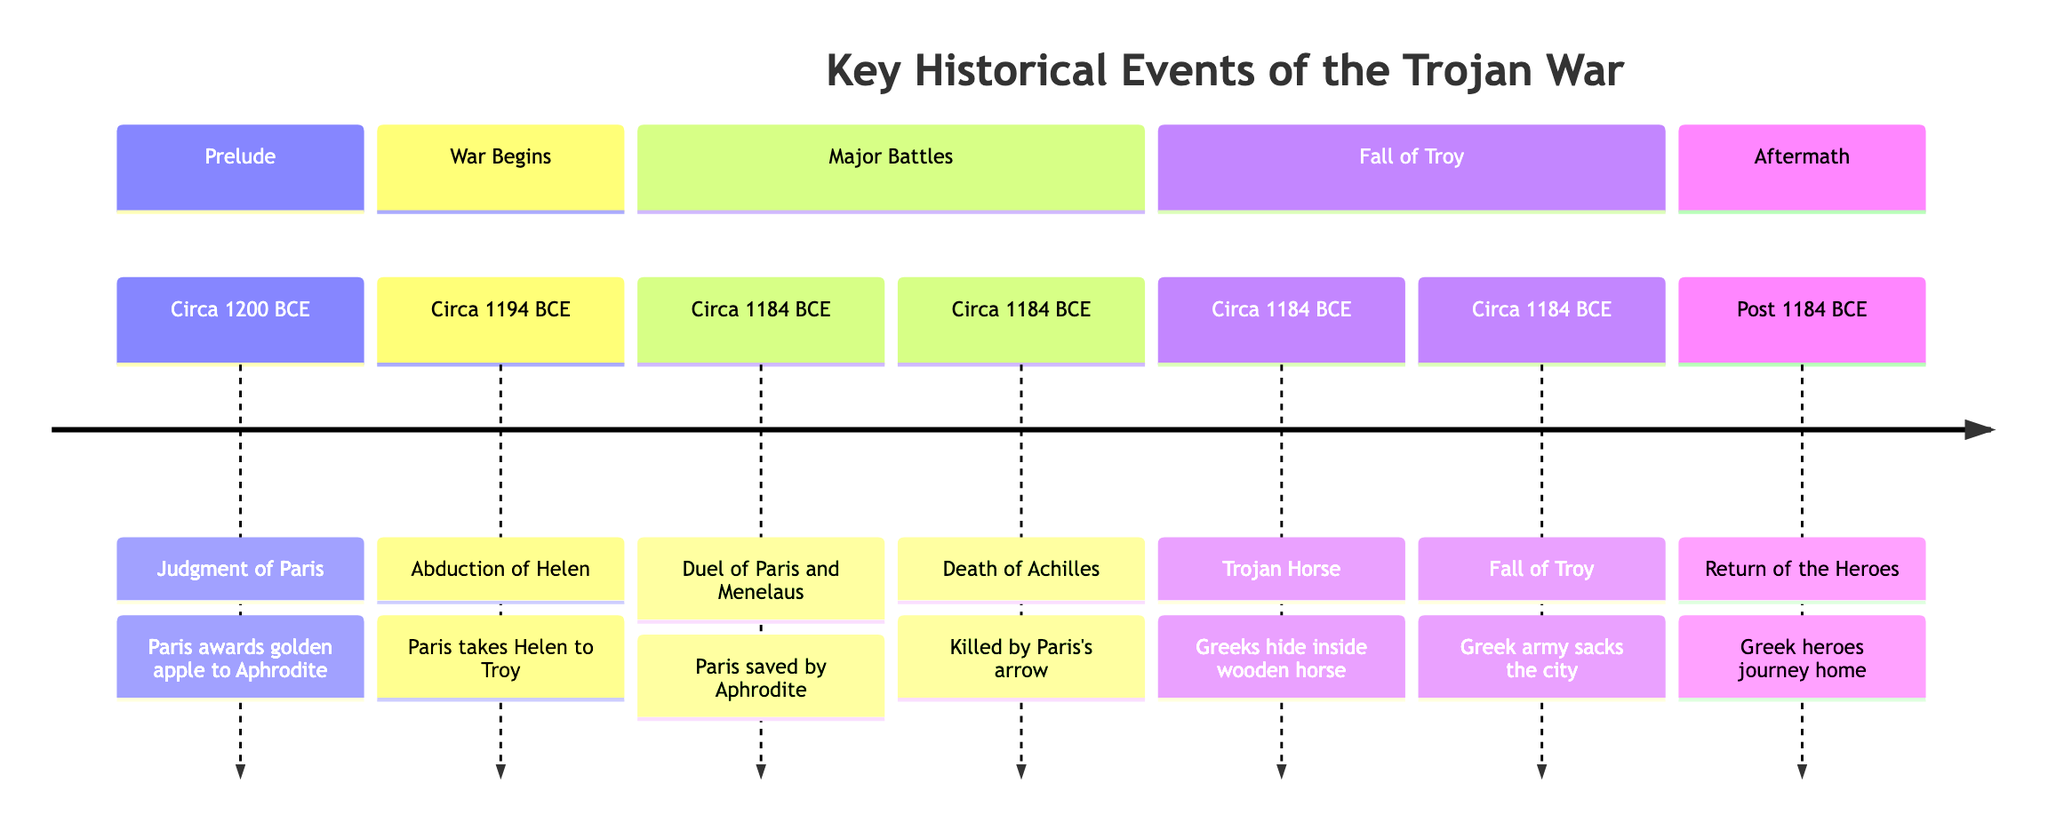What event marks the beginning of the Trojan War? According to the timeline, the event that marks the beginning of the Trojan War is the "Abduction of Helen," which occurred circa 1194 BCE. This event is situated after the "Judgment of Paris," indicating a direct cause-and-effect relationship.
Answer: Abduction of Helen How many key events are listed in the timeline? The timeline consists of seven key historical events related to the Trojan War, as evidenced by the distinct entries ranging from the "Judgment of Paris" to the "Return of the Heroes."
Answer: Seven What event occurred at the location "Fields of Troy"? The event that occurred at the "Fields of Troy" is the "Duel of Paris and Menelaus," which took place circa 1184 BCE. This can be confirmed by checking the timeline for the specified location.
Answer: Duel of Paris and Menelaus Which goddess did Paris choose in the Judgment of Paris? Paris awarded the golden apple to Aphrodite in the Judgment of Paris. This information is provided in the event description of the first event in the timeline.
Answer: Aphrodite What was the outcome of the Trojan Horse event? The outcome of the Trojan Horse event was the "Fall of Troy," which occurred as the Greek army entered the city after the Trojans brought the horse inside. This sequence of events is explicitly described in the timeline.
Answer: Fall of Troy Which event directly resulted from the abduction of Helen? The "Abduction of Helen" directly resulted in the outbreak of the Trojan War, evidenced by the placement of this event in the timeline preceding other significant events related to the conflict.
Answer: Trojan War What event marks the end of the timeline? The last event in the timeline is the "Return of the Heroes," which signifies the aftermath of the Trojan War, showcasing the conclusion of the main events listed.
Answer: Return of the Heroes 